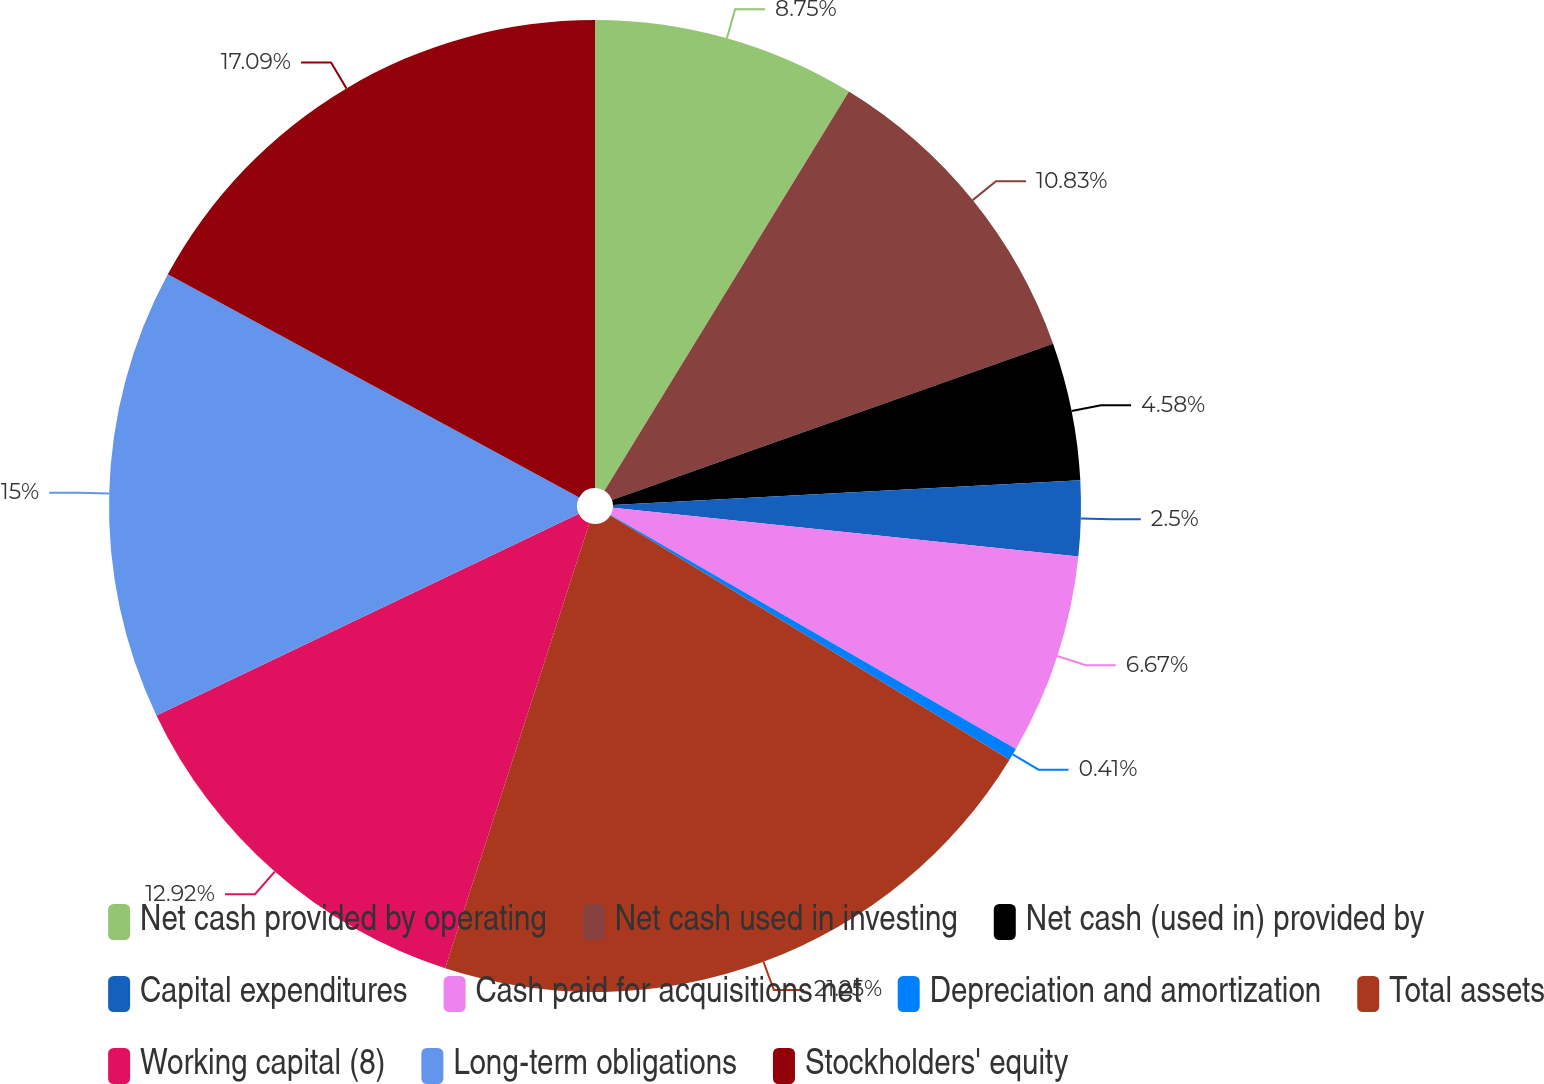Convert chart. <chart><loc_0><loc_0><loc_500><loc_500><pie_chart><fcel>Net cash provided by operating<fcel>Net cash used in investing<fcel>Net cash (used in) provided by<fcel>Capital expenditures<fcel>Cash paid for acquisitions net<fcel>Depreciation and amortization<fcel>Total assets<fcel>Working capital (8)<fcel>Long-term obligations<fcel>Stockholders' equity<nl><fcel>8.75%<fcel>10.83%<fcel>4.58%<fcel>2.5%<fcel>6.67%<fcel>0.41%<fcel>21.25%<fcel>12.92%<fcel>15.0%<fcel>17.09%<nl></chart> 